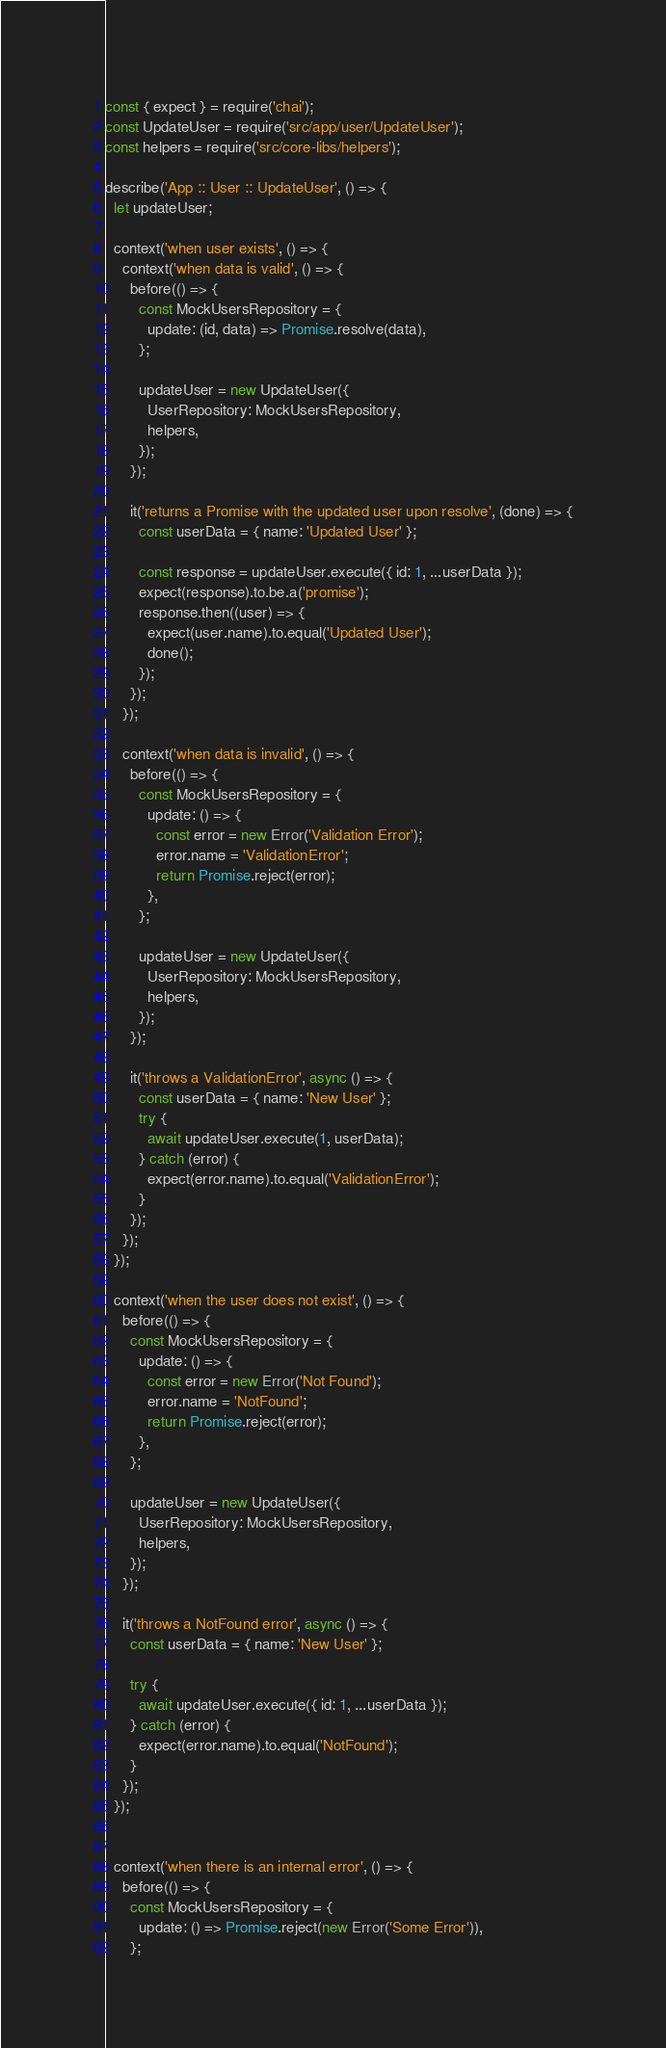<code> <loc_0><loc_0><loc_500><loc_500><_JavaScript_>const { expect } = require('chai');
const UpdateUser = require('src/app/user/UpdateUser');
const helpers = require('src/core-libs/helpers');

describe('App :: User :: UpdateUser', () => {
  let updateUser;

  context('when user exists', () => {
    context('when data is valid', () => {
      before(() => {
        const MockUsersRepository = {
          update: (id, data) => Promise.resolve(data),
        };

        updateUser = new UpdateUser({
          UserRepository: MockUsersRepository,
          helpers,
        });
      });

      it('returns a Promise with the updated user upon resolve', (done) => {
        const userData = { name: 'Updated User' };

        const response = updateUser.execute({ id: 1, ...userData });
        expect(response).to.be.a('promise');
        response.then((user) => {
          expect(user.name).to.equal('Updated User');
          done();
        });
      });
    });

    context('when data is invalid', () => {
      before(() => {
        const MockUsersRepository = {
          update: () => {
            const error = new Error('Validation Error');
            error.name = 'ValidationError';
            return Promise.reject(error);
          },
        };

        updateUser = new UpdateUser({
          UserRepository: MockUsersRepository,
          helpers,
        });
      });

      it('throws a ValidationError', async () => {
        const userData = { name: 'New User' };
        try {
          await updateUser.execute(1, userData);
        } catch (error) {
          expect(error.name).to.equal('ValidationError');
        }
      });
    });
  });

  context('when the user does not exist', () => {
    before(() => {
      const MockUsersRepository = {
        update: () => {
          const error = new Error('Not Found');
          error.name = 'NotFound';
          return Promise.reject(error);
        },
      };

      updateUser = new UpdateUser({
        UserRepository: MockUsersRepository,
        helpers,
      });
    });

    it('throws a NotFound error', async () => {
      const userData = { name: 'New User' };

      try {
        await updateUser.execute({ id: 1, ...userData });
      } catch (error) {
        expect(error.name).to.equal('NotFound');
      }
    });
  });


  context('when there is an internal error', () => {
    before(() => {
      const MockUsersRepository = {
        update: () => Promise.reject(new Error('Some Error')),
      };
</code> 